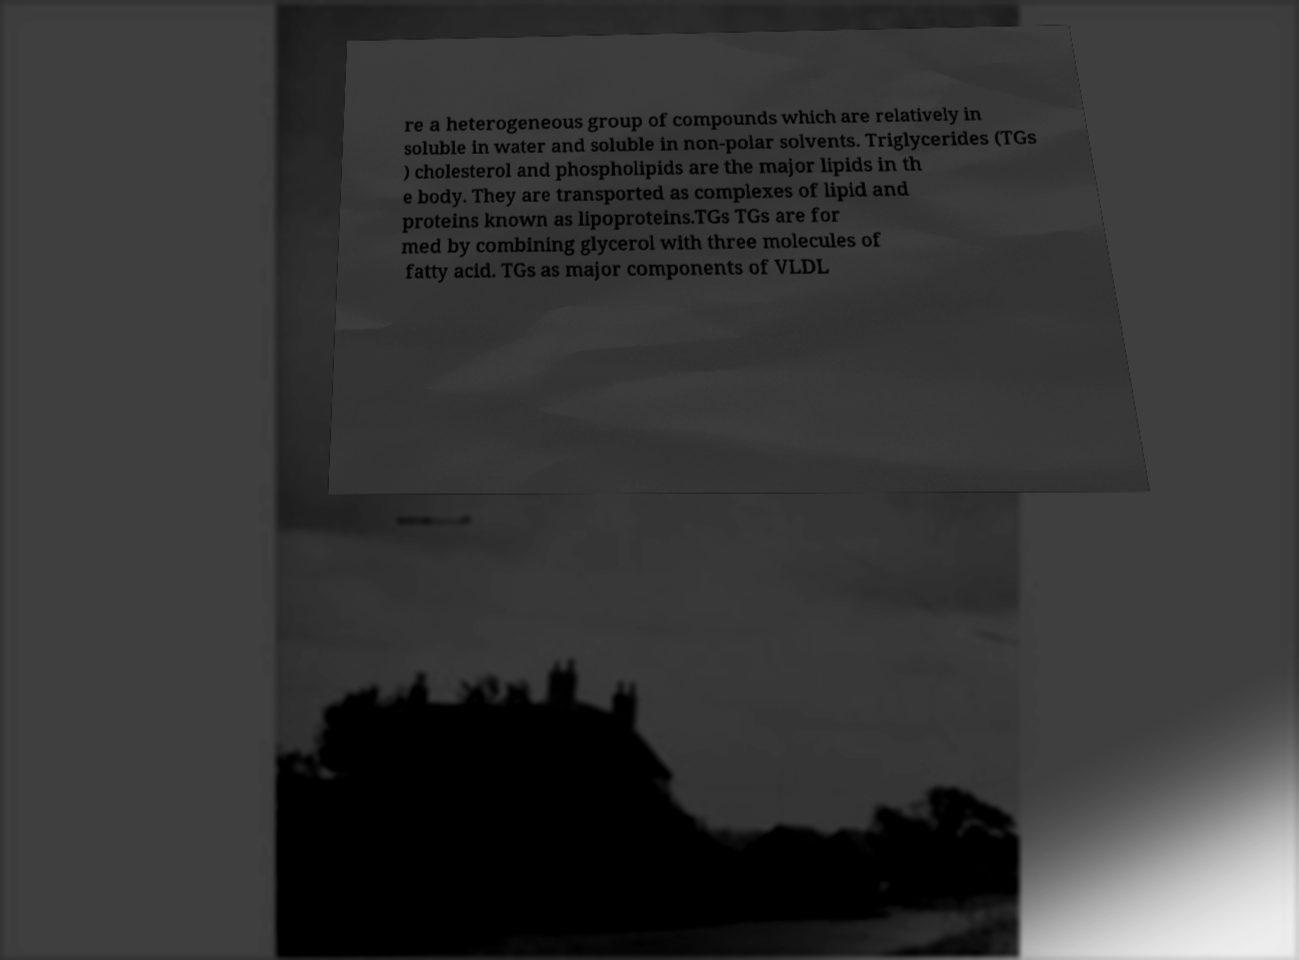Could you extract and type out the text from this image? re a heterogeneous group of compounds which are relatively in soluble in water and soluble in non-polar solvents. Triglycerides (TGs ) cholesterol and phospholipids are the major lipids in th e body. They are transported as complexes of lipid and proteins known as lipoproteins.TGs TGs are for med by combining glycerol with three molecules of fatty acid. TGs as major components of VLDL 